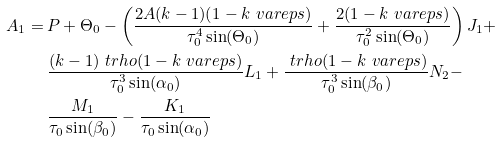Convert formula to latex. <formula><loc_0><loc_0><loc_500><loc_500>A _ { 1 } = \, & P + \Theta _ { 0 } - \left ( \frac { 2 A ( k - 1 ) ( 1 - k \ v a r e p s ) } { \tau _ { 0 } ^ { 4 } \sin ( \Theta _ { 0 } ) } + \frac { 2 ( 1 - k \ v a r e p s ) } { \tau _ { 0 } ^ { 2 } \sin ( \Theta _ { 0 } ) } \right ) J _ { 1 } + \\ & \frac { ( k - 1 ) \ t r h o ( 1 - k \ v a r e p s ) } { \tau _ { 0 } ^ { 3 } \sin ( \alpha _ { 0 } ) } L _ { 1 } + \frac { \ t r h o ( 1 - k \ v a r e p s ) } { \tau _ { 0 } ^ { 3 } \sin ( \beta _ { 0 } ) } N _ { 2 } - \\ & \frac { M _ { 1 } } { \tau _ { 0 } \sin ( \beta _ { 0 } ) } - \frac { K _ { 1 } } { \tau _ { 0 } \sin ( \alpha _ { 0 } ) }</formula> 